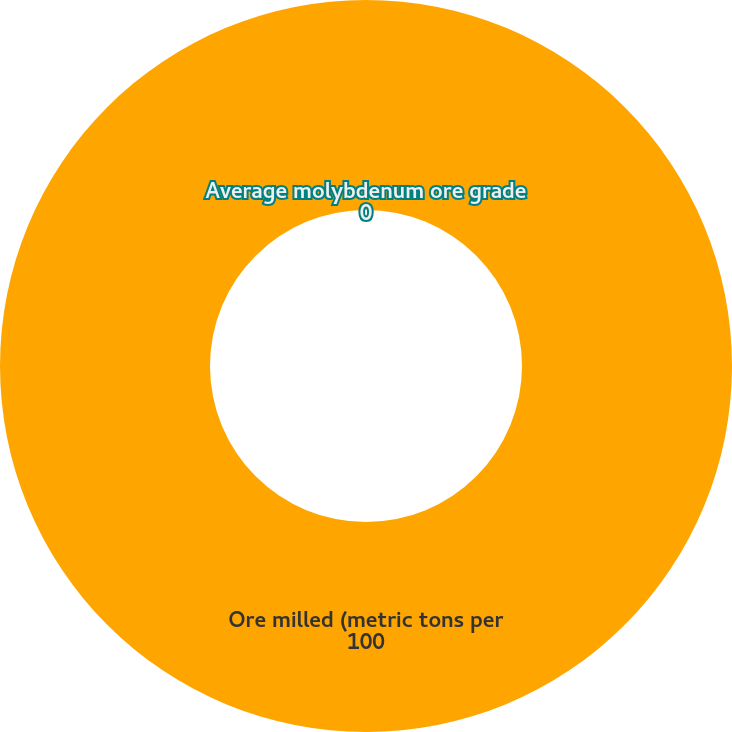<chart> <loc_0><loc_0><loc_500><loc_500><pie_chart><fcel>Ore milled (metric tons per<fcel>Average molybdenum ore grade<nl><fcel>100.0%<fcel>0.0%<nl></chart> 